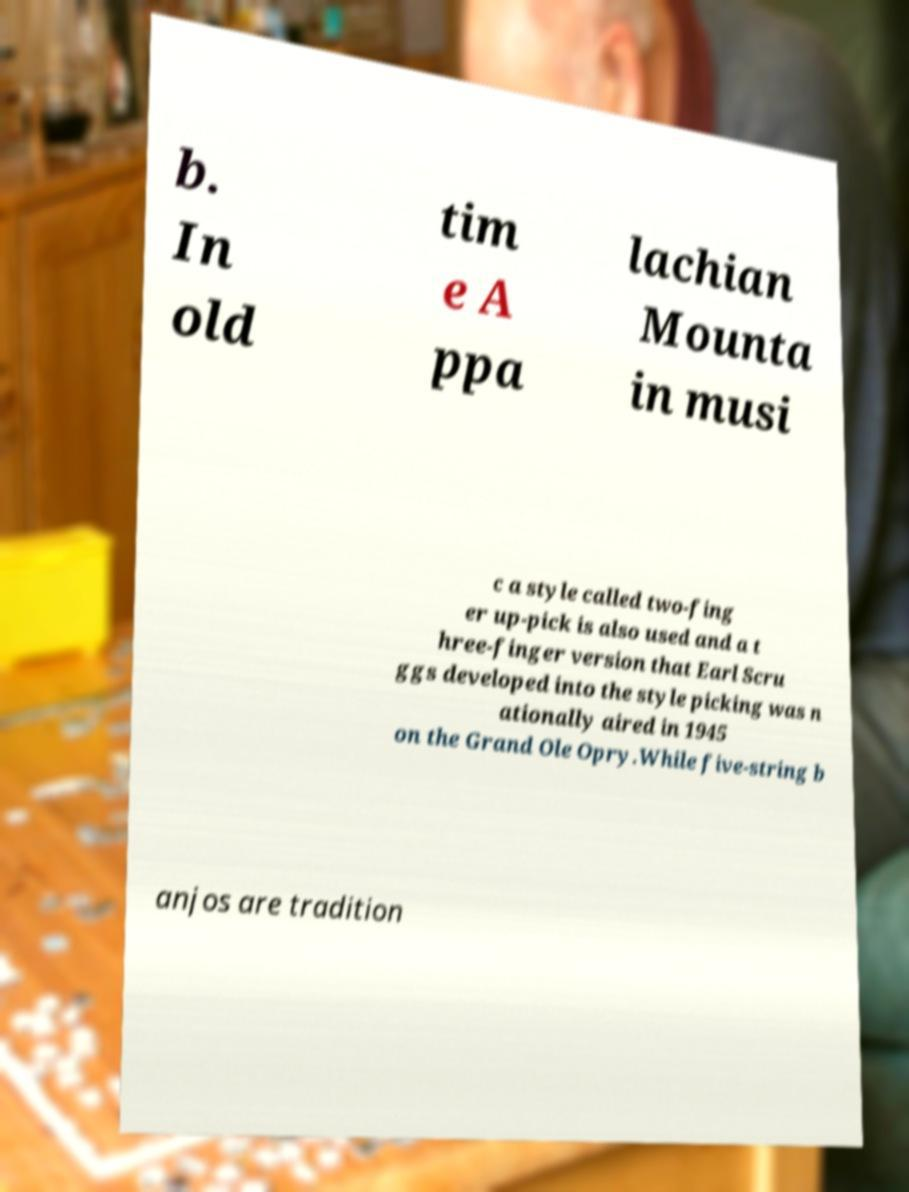Can you accurately transcribe the text from the provided image for me? b. In old tim e A ppa lachian Mounta in musi c a style called two-fing er up-pick is also used and a t hree-finger version that Earl Scru ggs developed into the style picking was n ationally aired in 1945 on the Grand Ole Opry.While five-string b anjos are tradition 